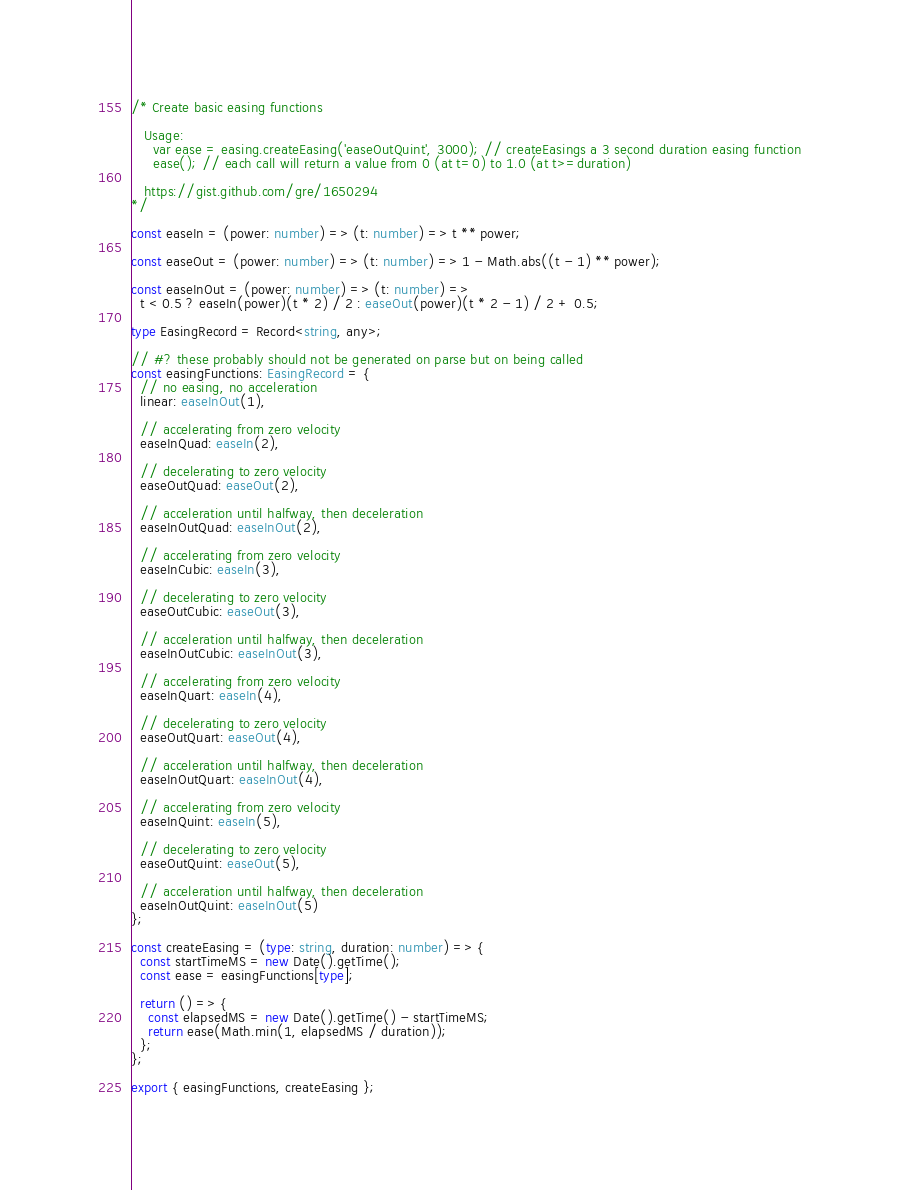<code> <loc_0><loc_0><loc_500><loc_500><_TypeScript_>/* Create basic easing functions

   Usage:
     var ease = easing.createEasing('easeOutQuint', 3000); // createEasings a 3 second duration easing function
     ease(); // each call will return a value from 0 (at t=0) to 1.0 (at t>=duration)

   https://gist.github.com/gre/1650294
*/

const easeIn = (power: number) => (t: number) => t ** power;

const easeOut = (power: number) => (t: number) => 1 - Math.abs((t - 1) ** power);

const easeInOut = (power: number) => (t: number) =>
  t < 0.5 ? easeIn(power)(t * 2) / 2 : easeOut(power)(t * 2 - 1) / 2 + 0.5;

type EasingRecord = Record<string, any>;

// #? these probably should not be generated on parse but on being called
const easingFunctions: EasingRecord = {
  // no easing, no acceleration
  linear: easeInOut(1),

  // accelerating from zero velocity
  easeInQuad: easeIn(2),

  // decelerating to zero velocity
  easeOutQuad: easeOut(2),

  // acceleration until halfway, then deceleration
  easeInOutQuad: easeInOut(2),

  // accelerating from zero velocity
  easeInCubic: easeIn(3),

  // decelerating to zero velocity
  easeOutCubic: easeOut(3),

  // acceleration until halfway, then deceleration
  easeInOutCubic: easeInOut(3),

  // accelerating from zero velocity
  easeInQuart: easeIn(4),

  // decelerating to zero velocity
  easeOutQuart: easeOut(4),

  // acceleration until halfway, then deceleration
  easeInOutQuart: easeInOut(4),

  // accelerating from zero velocity
  easeInQuint: easeIn(5),

  // decelerating to zero velocity
  easeOutQuint: easeOut(5),

  // acceleration until halfway, then deceleration
  easeInOutQuint: easeInOut(5)
};

const createEasing = (type: string, duration: number) => {
  const startTimeMS = new Date().getTime();
  const ease = easingFunctions[type];

  return () => {
    const elapsedMS = new Date().getTime() - startTimeMS;
    return ease(Math.min(1, elapsedMS / duration));
  };
};

export { easingFunctions, createEasing };
</code> 